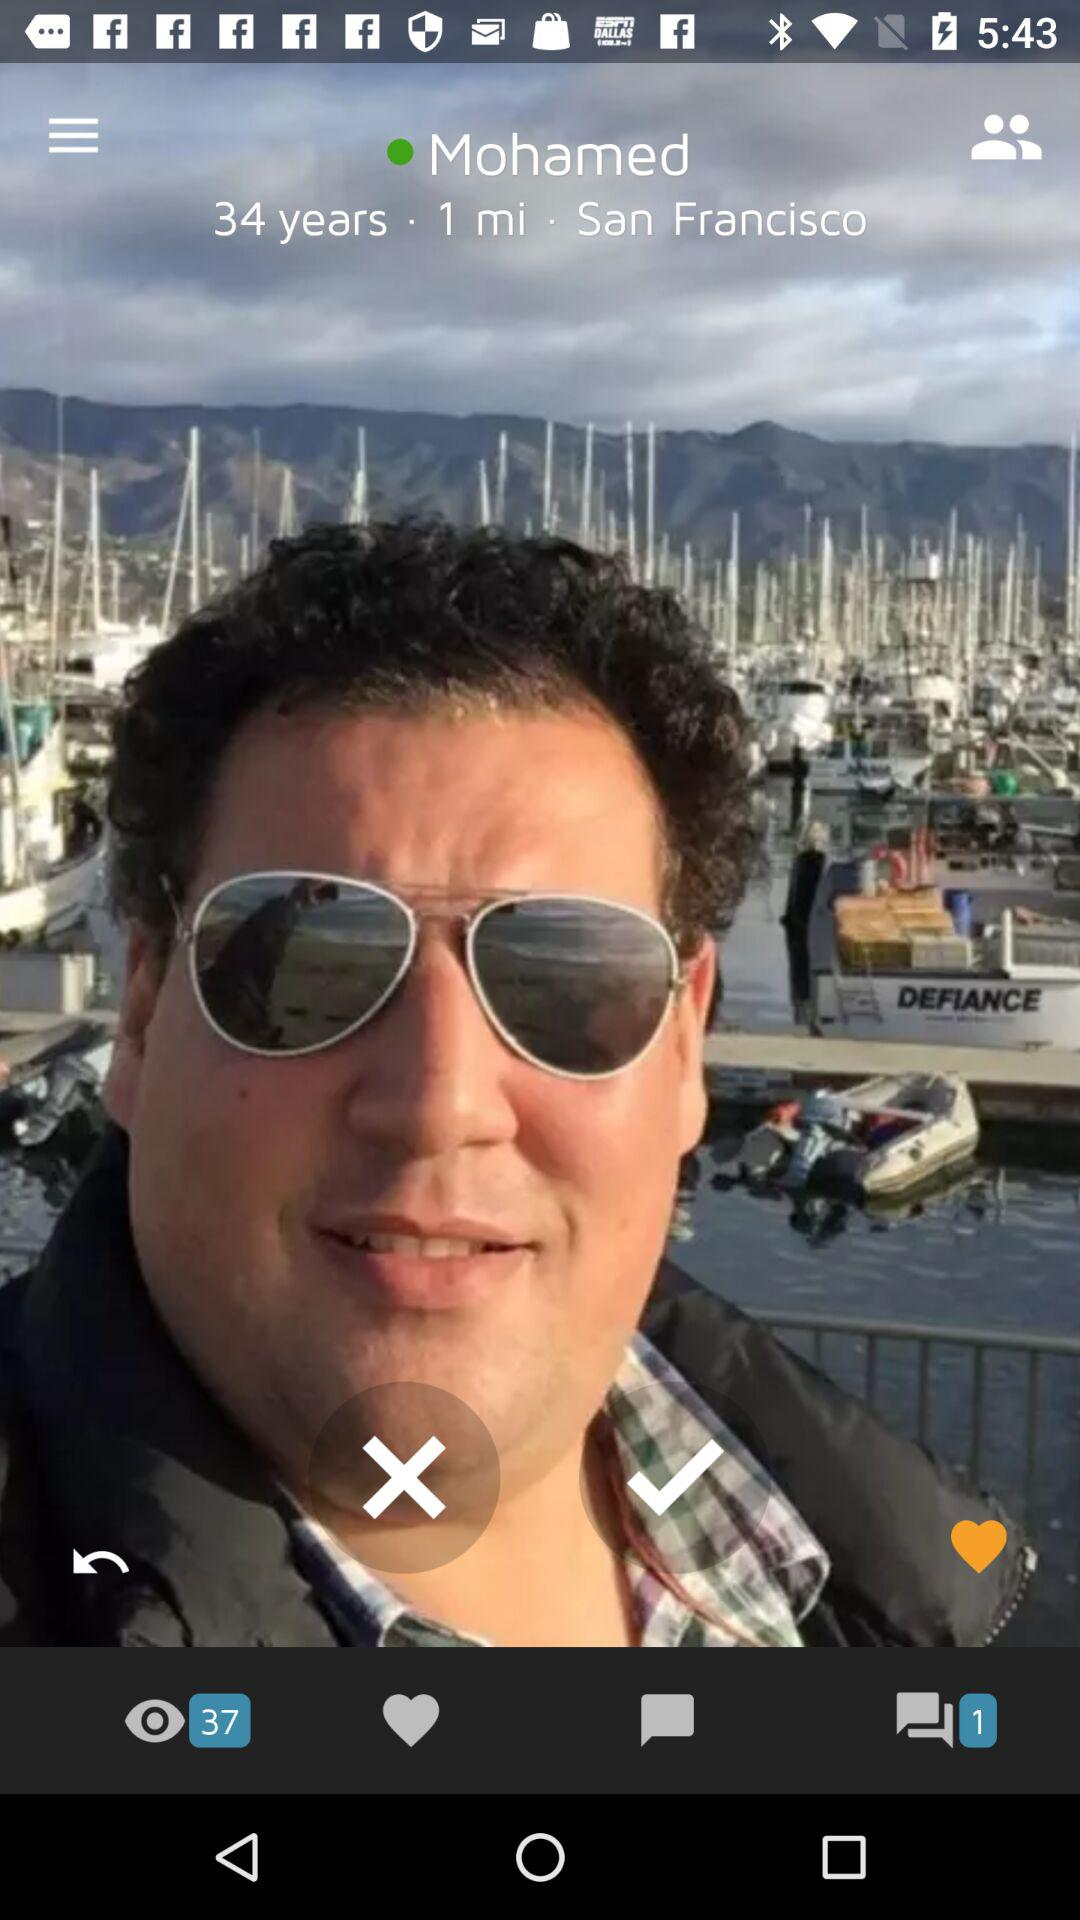What is the user's distance from the current location? The user's distance from the current location is 1 mile. 